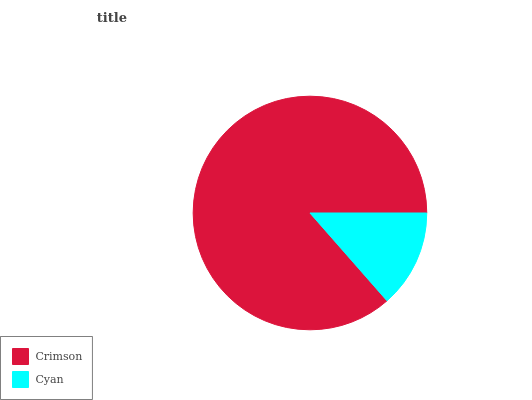Is Cyan the minimum?
Answer yes or no. Yes. Is Crimson the maximum?
Answer yes or no. Yes. Is Cyan the maximum?
Answer yes or no. No. Is Crimson greater than Cyan?
Answer yes or no. Yes. Is Cyan less than Crimson?
Answer yes or no. Yes. Is Cyan greater than Crimson?
Answer yes or no. No. Is Crimson less than Cyan?
Answer yes or no. No. Is Crimson the high median?
Answer yes or no. Yes. Is Cyan the low median?
Answer yes or no. Yes. Is Cyan the high median?
Answer yes or no. No. Is Crimson the low median?
Answer yes or no. No. 